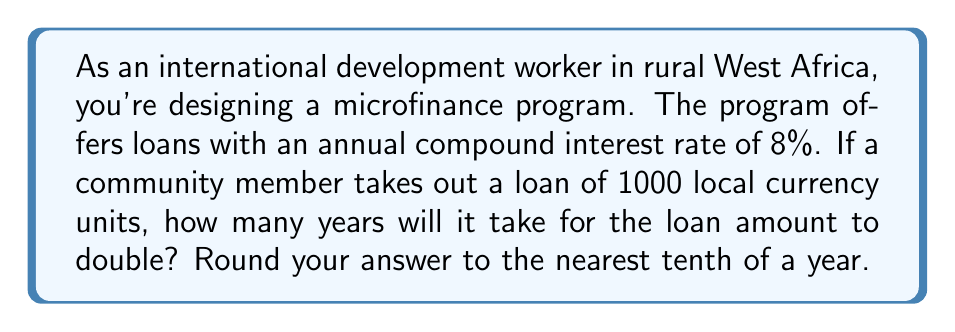Solve this math problem. To solve this problem, we'll use the compound interest formula and the properties of logarithms.

1) The compound interest formula is:
   $A = P(1 + r)^t$
   Where:
   $A$ = final amount
   $P$ = principal (initial investment)
   $r$ = annual interest rate (in decimal form)
   $t$ = time in years

2) We want to find when the amount doubles, so:
   $2P = P(1 + r)^t$

3) Dividing both sides by $P$:
   $2 = (1 + r)^t$

4) Taking the natural logarithm of both sides:
   $\ln(2) = \ln((1 + r)^t)$

5) Using the logarithm property $\ln(a^b) = b\ln(a)$:
   $\ln(2) = t\ln(1 + r)$

6) Solving for $t$:
   $t = \frac{\ln(2)}{\ln(1 + r)}$

7) Plugging in $r = 0.08$ (8% as a decimal):
   $t = \frac{\ln(2)}{\ln(1.08)}$

8) Calculating:
   $t \approx 9.006$ years

9) Rounding to the nearest tenth:
   $t \approx 9.0$ years
Answer: 9.0 years 